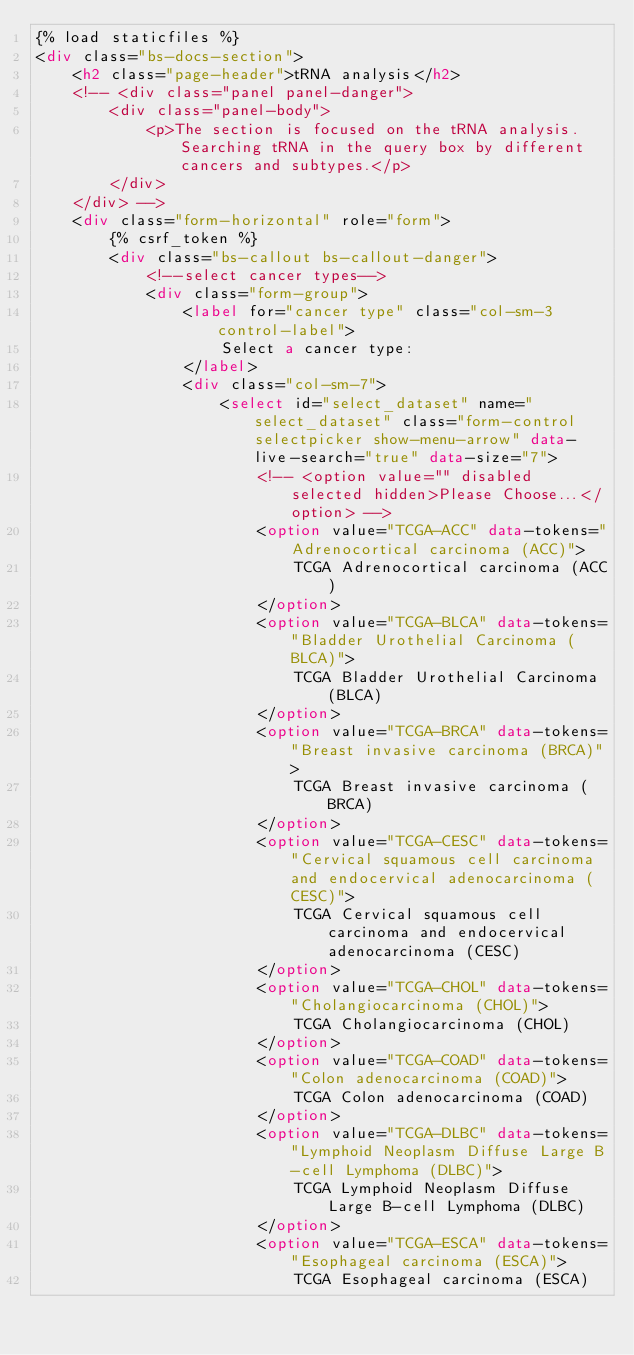<code> <loc_0><loc_0><loc_500><loc_500><_HTML_>{% load staticfiles %}
<div class="bs-docs-section">
    <h2 class="page-header">tRNA analysis</h2>
    <!-- <div class="panel panel-danger">
        <div class="panel-body">
            <p>The section is focused on the tRNA analysis. Searching tRNA in the query box by different cancers and subtypes.</p>
        </div>
    </div> -->
    <div class="form-horizontal" role="form">
        {% csrf_token %}
        <div class="bs-callout bs-callout-danger">
            <!--select cancer types-->
            <div class="form-group">
                <label for="cancer type" class="col-sm-3 control-label">
                    Select a cancer type:
                </label>
                <div class="col-sm-7">
                    <select id="select_dataset" name="select_dataset" class="form-control selectpicker show-menu-arrow" data-live-search="true" data-size="7">
                        <!-- <option value="" disabled selected hidden>Please Choose...</option> -->
                        <option value="TCGA-ACC" data-tokens="Adrenocortical carcinoma (ACC)">
                            TCGA Adrenocortical carcinoma (ACC)
                        </option>
                        <option value="TCGA-BLCA" data-tokens="Bladder Urothelial Carcinoma (BLCA)">
                            TCGA Bladder Urothelial Carcinoma (BLCA)
                        </option>
                        <option value="TCGA-BRCA" data-tokens="Breast invasive carcinoma (BRCA)">
                            TCGA Breast invasive carcinoma (BRCA)
                        </option>
                        <option value="TCGA-CESC" data-tokens="Cervical squamous cell carcinoma and endocervical adenocarcinoma (CESC)">
                            TCGA Cervical squamous cell carcinoma and endocervical adenocarcinoma (CESC)
                        </option>
                        <option value="TCGA-CHOL" data-tokens="Cholangiocarcinoma (CHOL)">
                            TCGA Cholangiocarcinoma (CHOL)
                        </option>
                        <option value="TCGA-COAD" data-tokens="Colon adenocarcinoma (COAD)">
                            TCGA Colon adenocarcinoma (COAD)
                        </option>
                        <option value="TCGA-DLBC" data-tokens="Lymphoid Neoplasm Diffuse Large B-cell Lymphoma (DLBC)">
                            TCGA Lymphoid Neoplasm Diffuse Large B-cell Lymphoma (DLBC)
                        </option>
                        <option value="TCGA-ESCA" data-tokens="Esophageal carcinoma (ESCA)">
                            TCGA Esophageal carcinoma (ESCA)</code> 